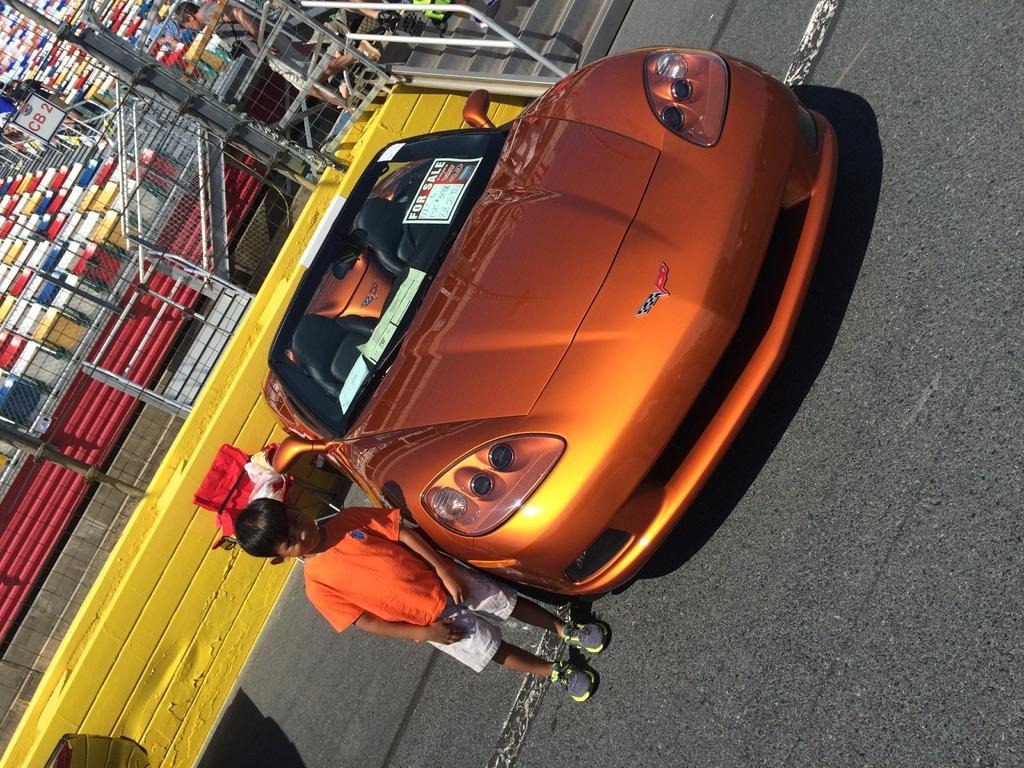Who is the main subject in the image? There is a boy in the image. What can be seen on the road in the image? There is a vehicle on the road in the image. What is visible in the distance behind the boy? There are people and objects visible in the background of the image. What type of jewel can be seen in the river in the image? There is no river or jewel present in the image. 